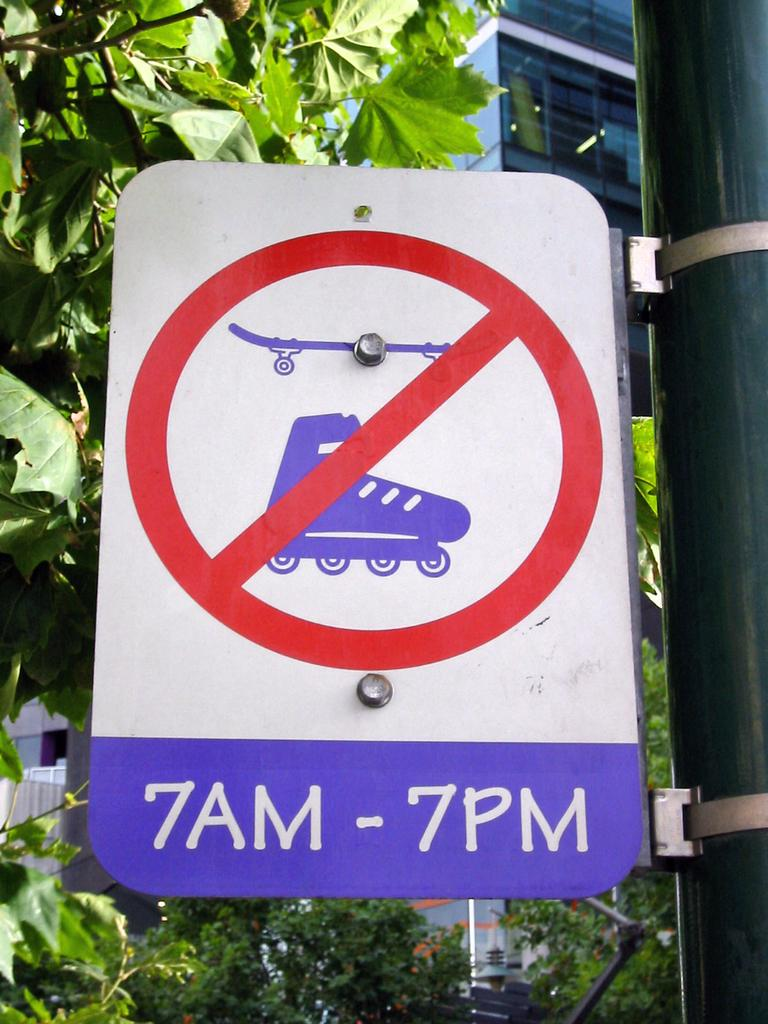What is the main object in the image? There is a pole in the image. What is attached to the pole? There is a sign board on the pole. Can you describe the sign board? The sign board contains 2 numbers and 4 alphabets. What can be seen in the background of the image? There are leaves on stems and a building visible in the background of the image. Is there a basketball game happening near the pole in the image? There is no indication of a basketball game or any sports activity in the image. 